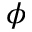Convert formula to latex. <formula><loc_0><loc_0><loc_500><loc_500>\phi</formula> 